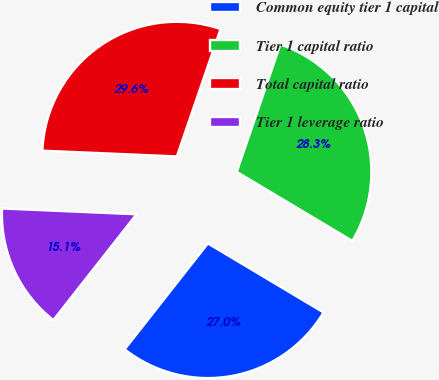Convert chart. <chart><loc_0><loc_0><loc_500><loc_500><pie_chart><fcel>Common equity tier 1 capital<fcel>Tier 1 capital ratio<fcel>Total capital ratio<fcel>Tier 1 leverage ratio<nl><fcel>27.04%<fcel>28.31%<fcel>29.57%<fcel>15.08%<nl></chart> 